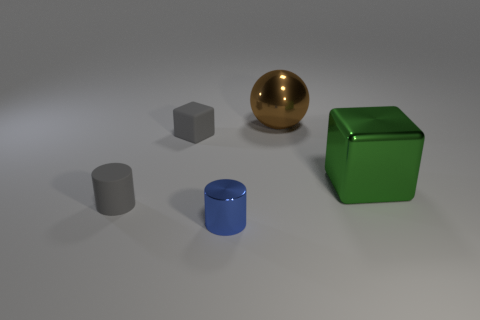What is the shape of the brown thing?
Keep it short and to the point. Sphere. What number of gray objects are big shiny cylinders or cubes?
Provide a succinct answer. 1. There is a brown object that is the same material as the green block; what is its size?
Give a very brief answer. Large. Is the material of the gray object that is in front of the rubber cube the same as the small object behind the large green metal cube?
Offer a very short reply. Yes. How many blocks are small metallic things or large gray matte objects?
Your response must be concise. 0. What number of green metal objects are behind the gray matte thing that is behind the cylinder that is left of the blue thing?
Your response must be concise. 0. What material is the other small object that is the same shape as the green thing?
Keep it short and to the point. Rubber. There is a block in front of the rubber block; what color is it?
Your answer should be very brief. Green. Is the material of the blue thing the same as the large object that is in front of the gray block?
Provide a short and direct response. Yes. What is the big sphere made of?
Offer a terse response. Metal. 